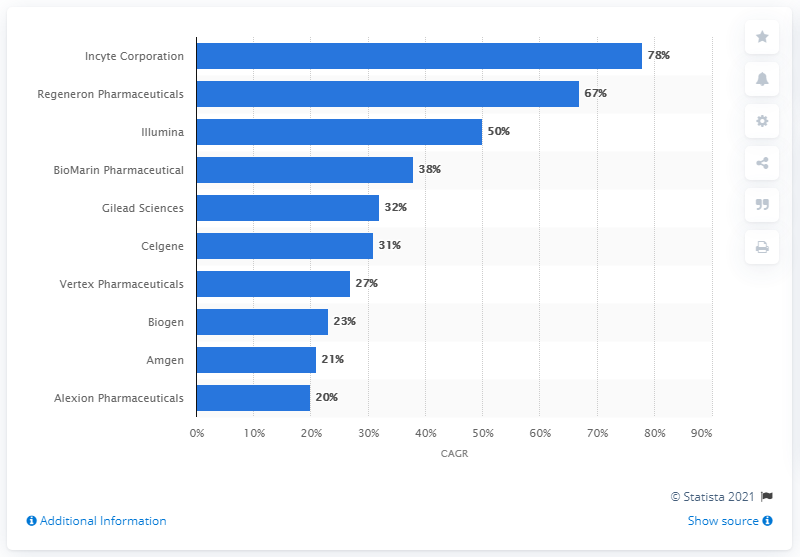Highlight a few significant elements in this photo. Amgen's market capitalization grew at a compound annual growth rate (CAGR) of 21% between 2012 and 2016. 